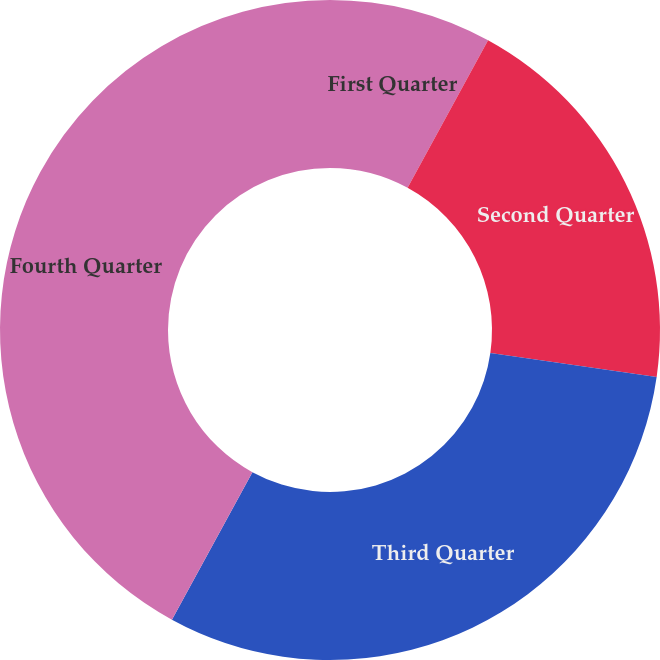Convert chart. <chart><loc_0><loc_0><loc_500><loc_500><pie_chart><fcel>First Quarter<fcel>Second Quarter<fcel>Third Quarter<fcel>Fourth Quarter<nl><fcel>7.95%<fcel>19.32%<fcel>30.68%<fcel>42.05%<nl></chart> 